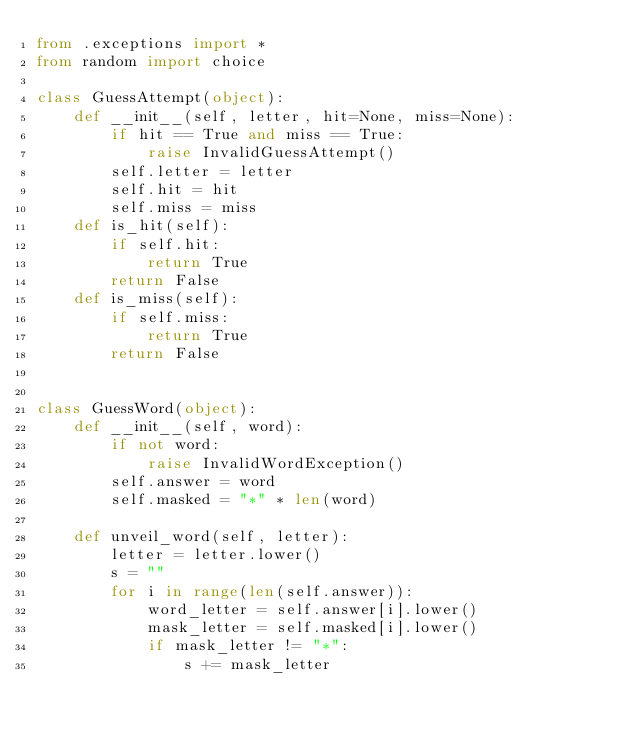<code> <loc_0><loc_0><loc_500><loc_500><_Python_>from .exceptions import *
from random import choice

class GuessAttempt(object):
    def __init__(self, letter, hit=None, miss=None):
        if hit == True and miss == True:
            raise InvalidGuessAttempt()
        self.letter = letter
        self.hit = hit
        self.miss = miss
    def is_hit(self):
        if self.hit:
            return True
        return False
    def is_miss(self):
        if self.miss:
            return True
        return False


class GuessWord(object):
    def __init__(self, word):
        if not word:
            raise InvalidWordException()
        self.answer = word
        self.masked = "*" * len(word)
        
    def unveil_word(self, letter):
        letter = letter.lower()
        s = ""
        for i in range(len(self.answer)):
            word_letter = self.answer[i].lower()
            mask_letter = self.masked[i].lower()
            if mask_letter != "*":
                s += mask_letter</code> 